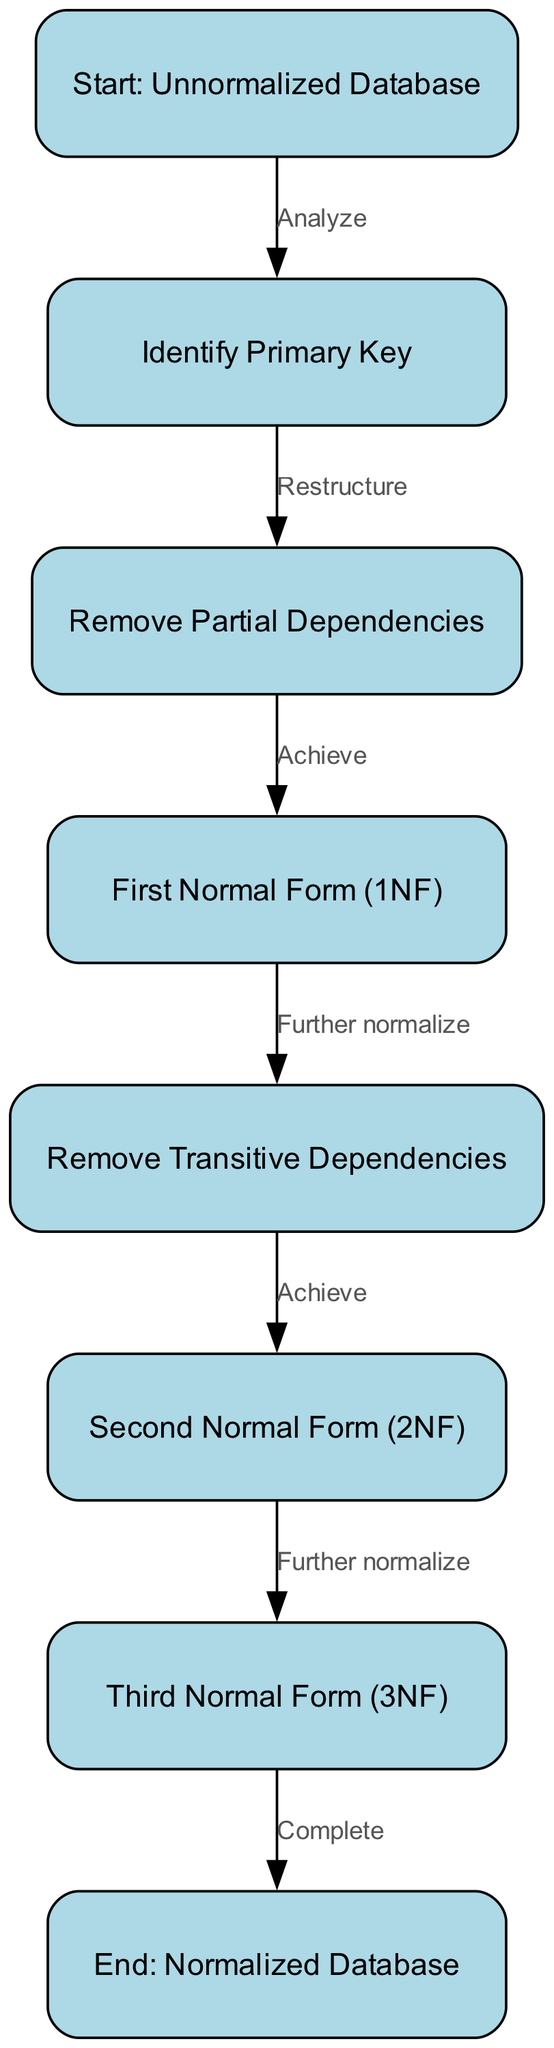What is the first step in the normalization process? The diagram starts with the node labeled "Start: Unnormalized Database," which indicates that the process begins with an unnormalized database.
Answer: Start: Unnormalized Database How many nodes are present in the diagram? By analyzing the diagram, we can count the total number of nodes listed, which are eight in total, representing various steps in the normalization process.
Answer: Eight What is the output after achieving First Normal Form? After reaching the "First Normal Form (1NF)" node, the next step according to the diagram is "Remove Transitive Dependencies." Thus, the output is the action that follows 1NF, which is aiming to "Remove Transitive Dependencies."
Answer: Remove Transitive Dependencies Which node follows "Remove Partial Dependencies"? According to the flow of the diagram, after "Remove Partial Dependencies," the flow leads to "First Normal Form (1NF)." Thus, this is the node that follows it directly in the process.
Answer: First Normal Form (1NF) What process is described between the "Second Normal Form (2NF)" and "Third Normal Form (3NF)"? The diagram indicates that between these two nodes, the action is "Further normalize," which is the process that facilitates the transition from 2NF to 3NF.
Answer: Further normalize What is the final output of the normalization process? The last node in the flowchart is "End: Normalized Database," which signifies that this is the final output after completing all normalization steps.
Answer: End: Normalized Database How many edges are there in total in the diagram? By counting the connections (edges) between the nodes, we can determine that there are seven edges that represent the steps taken from one node to another in the normalization process.
Answer: Seven What transition occurs after achieving Third Normal Form? After reaching the "Third Normal Form (3NF)," the next action defined in the diagram is the completion of the entire process, indicated by "Complete."
Answer: Complete 